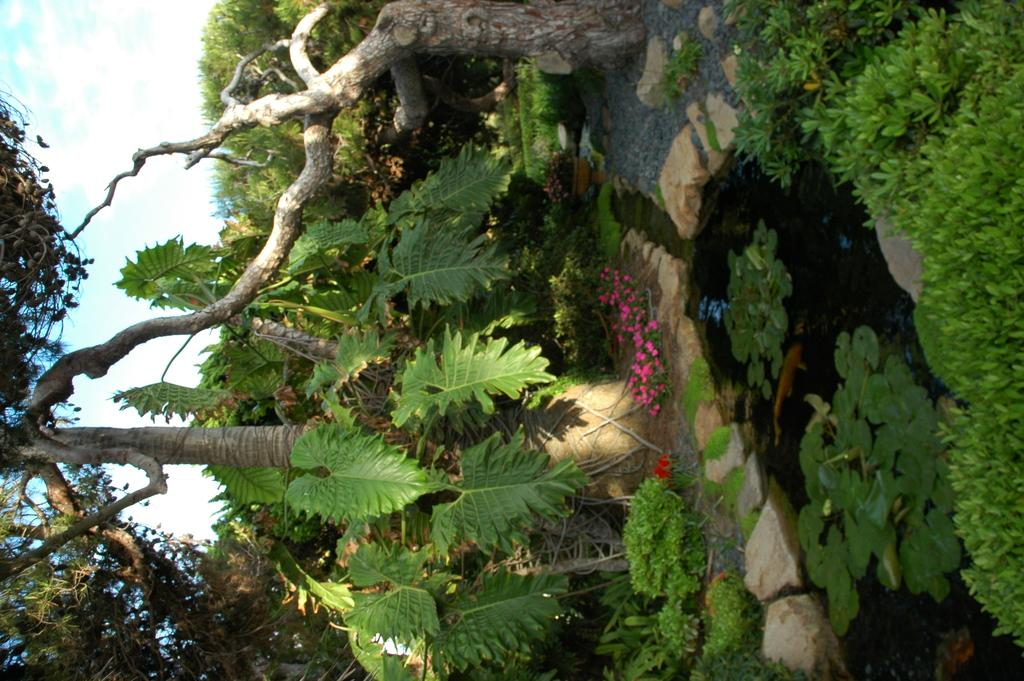How is the image oriented? The image is tilted. What can be seen in the sky in the image? There is sky visible in the image. What type of vegetation is present in the image? There are trees, plants, and flowers visible in the image. What is the water feature in the image? There is a water pond in the image. What parts of the plants are visible in the image? Leaves, branches, and flowers are visible in the image. Can you hear the owl hooting through the window in the image? There is no owl or window present in the image, so it is not possible to hear any sounds or see a window. 